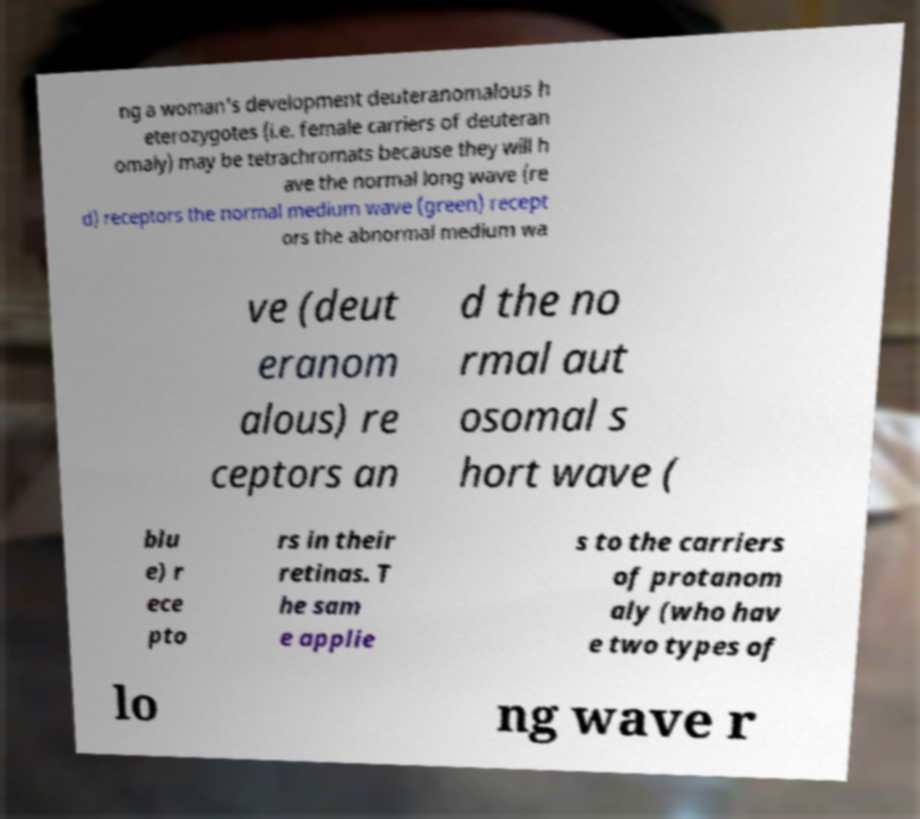What messages or text are displayed in this image? I need them in a readable, typed format. ng a woman's development deuteranomalous h eterozygotes (i.e. female carriers of deuteran omaly) may be tetrachromats because they will h ave the normal long wave (re d) receptors the normal medium wave (green) recept ors the abnormal medium wa ve (deut eranom alous) re ceptors an d the no rmal aut osomal s hort wave ( blu e) r ece pto rs in their retinas. T he sam e applie s to the carriers of protanom aly (who hav e two types of lo ng wave r 